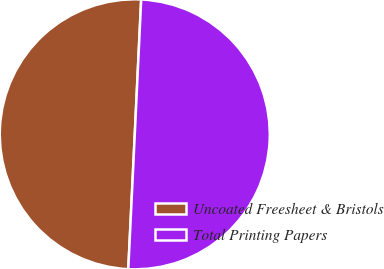Convert chart. <chart><loc_0><loc_0><loc_500><loc_500><pie_chart><fcel>Uncoated Freesheet & Bristols<fcel>Total Printing Papers<nl><fcel>49.99%<fcel>50.01%<nl></chart> 